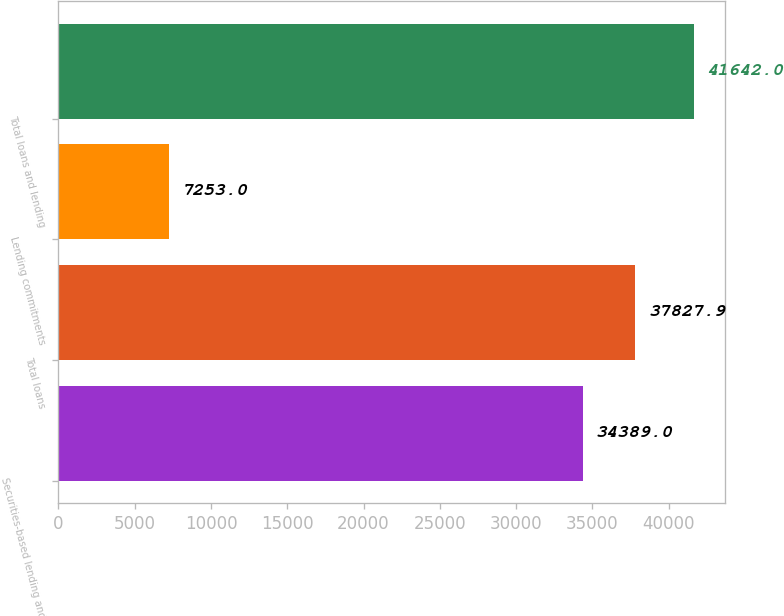Convert chart to OTSL. <chart><loc_0><loc_0><loc_500><loc_500><bar_chart><fcel>Securities-based lending and<fcel>Total loans<fcel>Lending commitments<fcel>Total loans and lending<nl><fcel>34389<fcel>37827.9<fcel>7253<fcel>41642<nl></chart> 